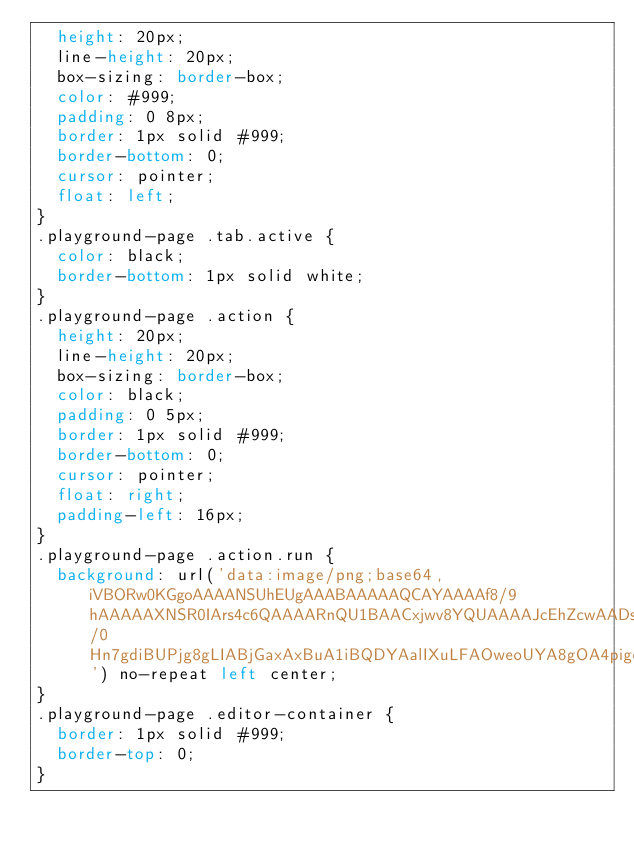Convert code to text. <code><loc_0><loc_0><loc_500><loc_500><_CSS_>	height: 20px;
	line-height: 20px;
	box-sizing: border-box;
	color: #999;
	padding: 0 8px;
	border: 1px solid #999;
	border-bottom: 0;
	cursor: pointer;
	float: left;
}
.playground-page .tab.active {
	color: black;
	border-bottom: 1px solid white;
}
.playground-page .action {
	height: 20px;
	line-height: 20px;
	box-sizing: border-box;
	color: black;
	padding: 0 5px;
	border: 1px solid #999;
	border-bottom: 0;
	cursor: pointer;
	float: right;
	padding-left: 16px;
}
.playground-page .action.run {
	background: url('data:image/png;base64,iVBORw0KGgoAAAANSUhEUgAAABAAAAAQCAYAAAAf8/9hAAAAAXNSR0IArs4c6QAAAARnQU1BAACxjwv8YQUAAAAJcEhZcwAADsMAAA7DAcdvqGQAAAAadEVYdFNvZnR3YXJlAFBhaW50Lk5FVCB2My41LjEwMPRyoQAAAE1JREFUOE9jKCsrY6AEU6QZZPHgNeA/0Hn7gdiBUPjg8gLIABjGaxAxBuA1iBQDYAalIXuLFAOweoUYA8gOA4pigegERrRCXOlhGBgAAGmggVf7bEk0AAAAAElFTkSuQmCC') no-repeat left center;
}
.playground-page .editor-container {
	border: 1px solid #999;
	border-top: 0;
}


</code> 